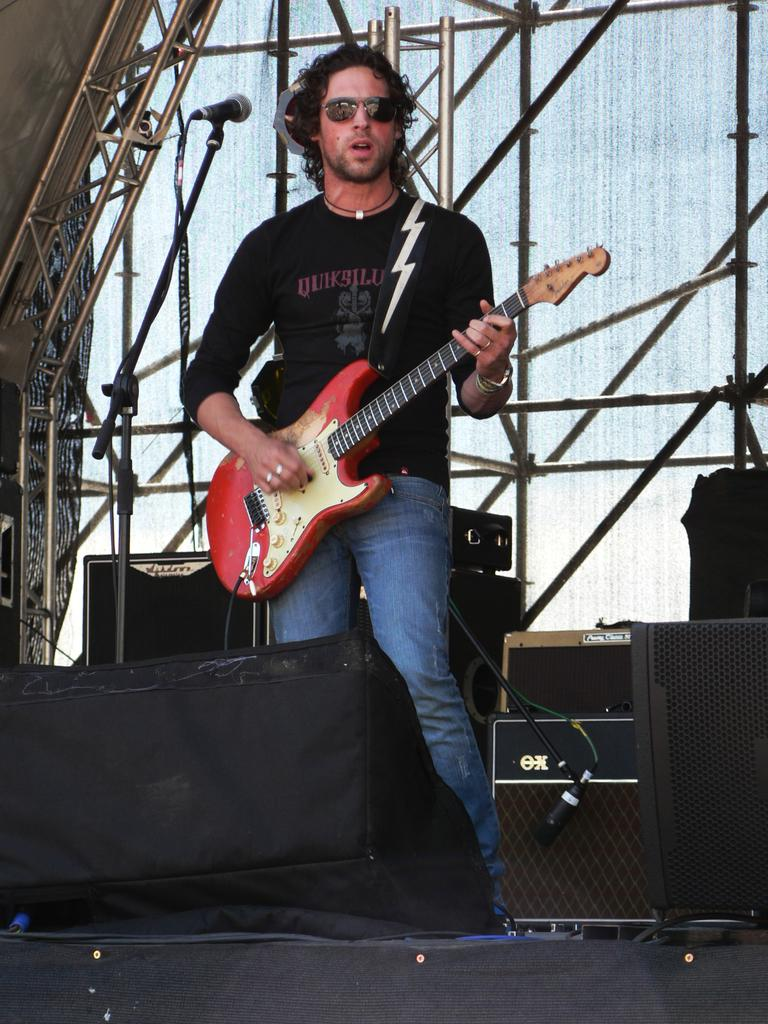What is the man doing on the stage in the image? The man is playing a guitar on the stage. What is the man wearing in the image? The man is wearing a black t-shirt in the image. What object is placed beside the man on the stage? There is a sound box placed beside the man on the stage. What can be seen at the back of the stage? There is an iron rod construction at the back of the stage. What type of oatmeal is being served on the stage in the image? There is no oatmeal present in the image; the man is playing a guitar on the stage. What is the man using to secure the guitar to the stage in the image? The man is not using a chain or any other securing device to hold the guitar in the image; he is simply playing it. 